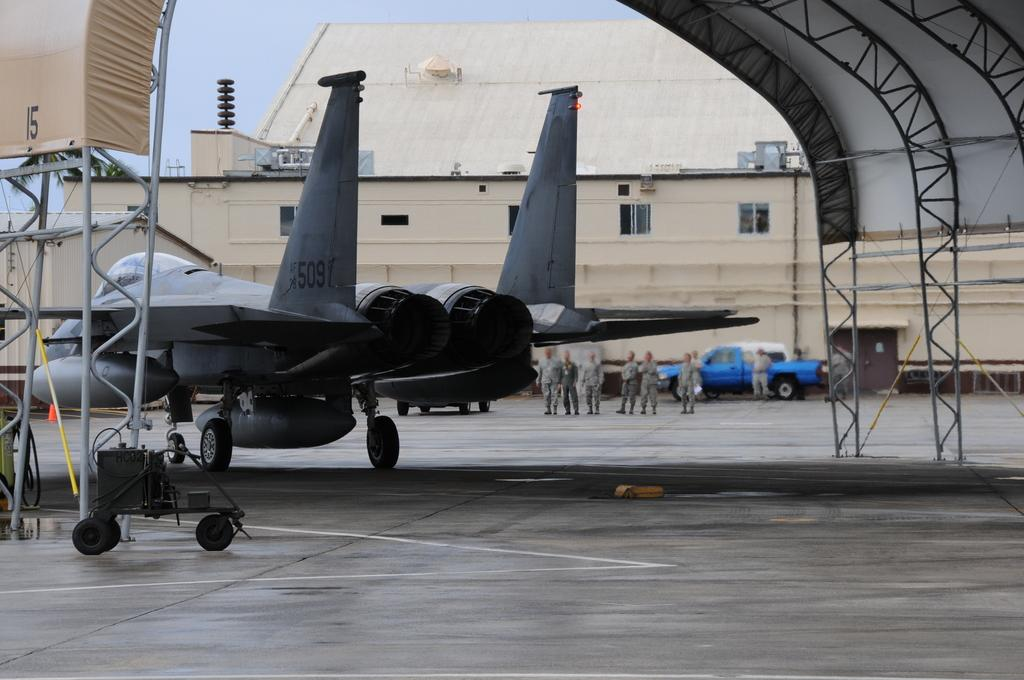Provide a one-sentence caption for the provided image. A jet sitting in a military air hangar with the numbers 509 written on its rudder. 